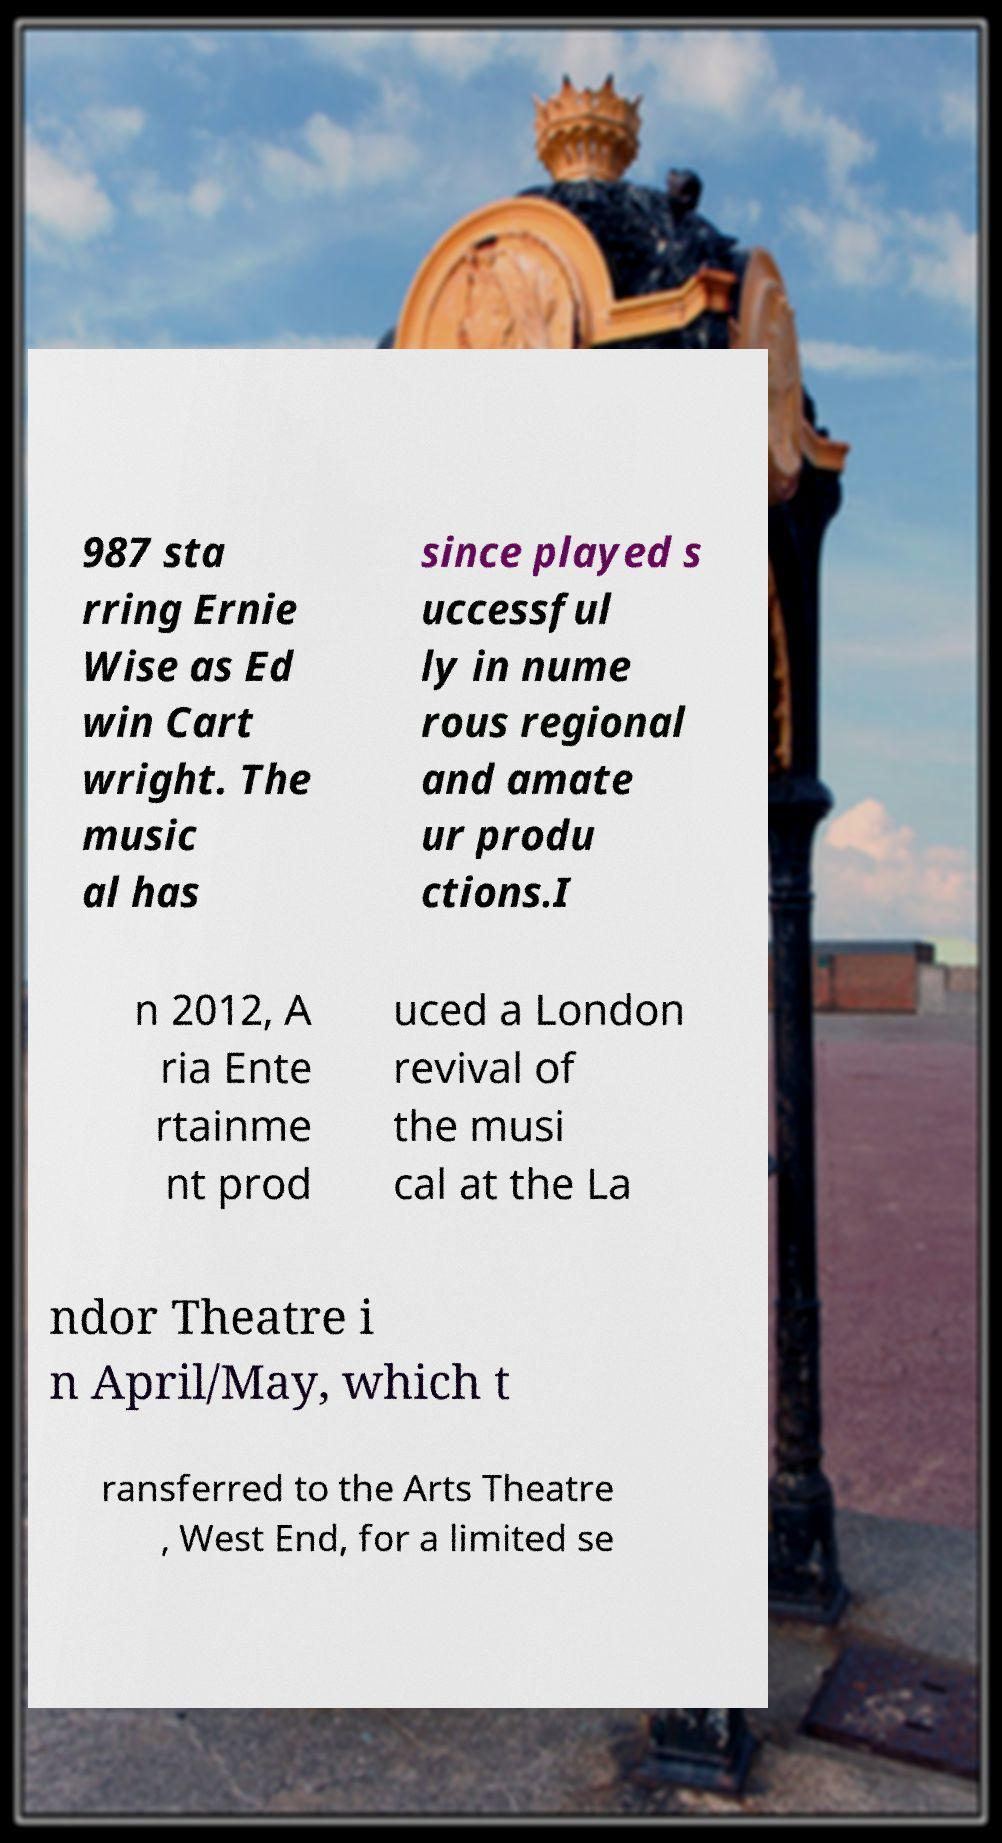Could you extract and type out the text from this image? 987 sta rring Ernie Wise as Ed win Cart wright. The music al has since played s uccessful ly in nume rous regional and amate ur produ ctions.I n 2012, A ria Ente rtainme nt prod uced a London revival of the musi cal at the La ndor Theatre i n April/May, which t ransferred to the Arts Theatre , West End, for a limited se 